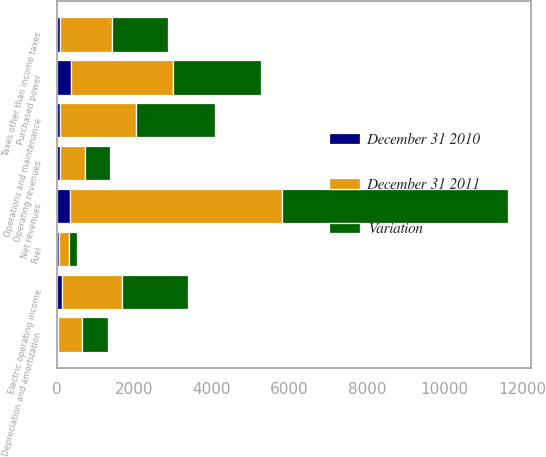<chart> <loc_0><loc_0><loc_500><loc_500><stacked_bar_chart><ecel><fcel>Operating revenues<fcel>Purchased power<fcel>Fuel<fcel>Net revenues<fcel>Operations and maintenance<fcel>Depreciation and amortization<fcel>Taxes other than income taxes<fcel>Electric operating income<nl><fcel>Variation<fcel>639.5<fcel>2260<fcel>199<fcel>5821<fcel>2041<fcel>656<fcel>1429<fcel>1695<nl><fcel>December 31 2011<fcel>639.5<fcel>2629<fcel>256<fcel>5491<fcel>1963<fcel>623<fcel>1356<fcel>1549<nl><fcel>December 31 2010<fcel>96<fcel>369<fcel>57<fcel>330<fcel>78<fcel>33<fcel>73<fcel>146<nl></chart> 